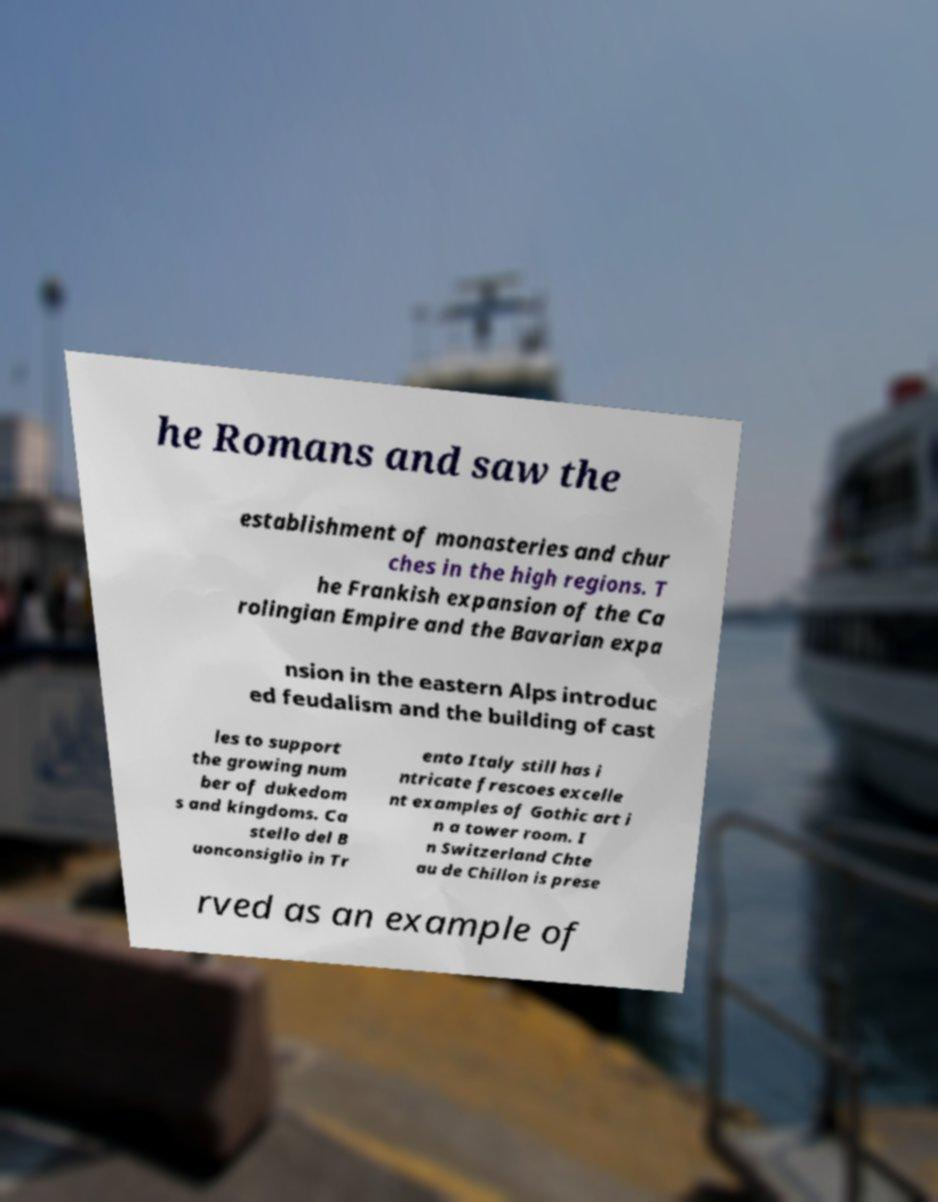Could you extract and type out the text from this image? he Romans and saw the establishment of monasteries and chur ches in the high regions. T he Frankish expansion of the Ca rolingian Empire and the Bavarian expa nsion in the eastern Alps introduc ed feudalism and the building of cast les to support the growing num ber of dukedom s and kingdoms. Ca stello del B uonconsiglio in Tr ento Italy still has i ntricate frescoes excelle nt examples of Gothic art i n a tower room. I n Switzerland Chte au de Chillon is prese rved as an example of 